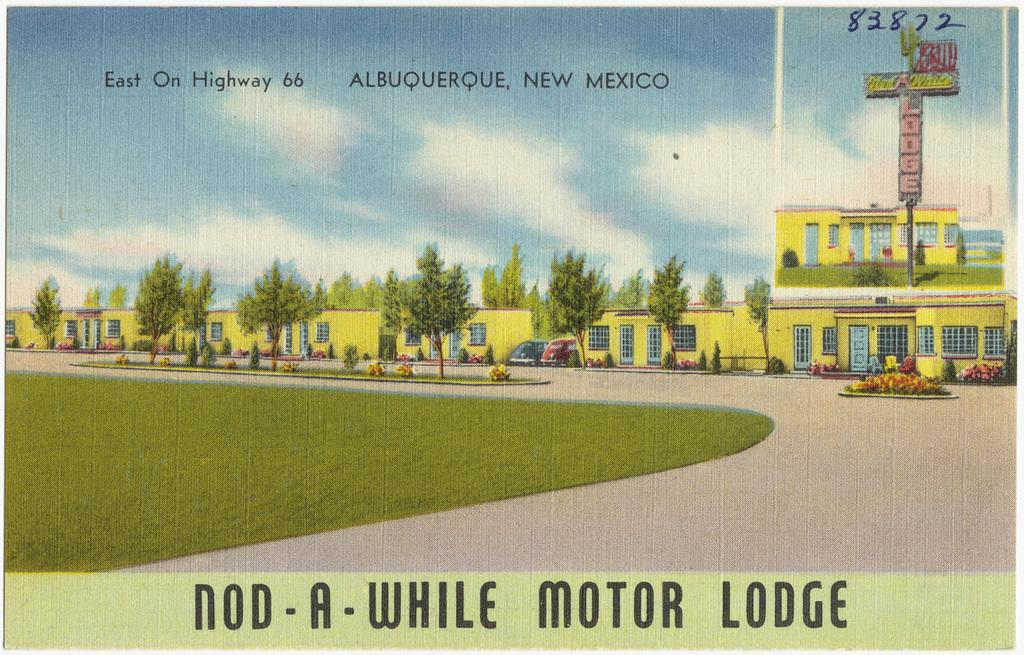<image>
Write a terse but informative summary of the picture. The Nod-A-While Motor Lodge is in Albuquerque, New Mexico. 